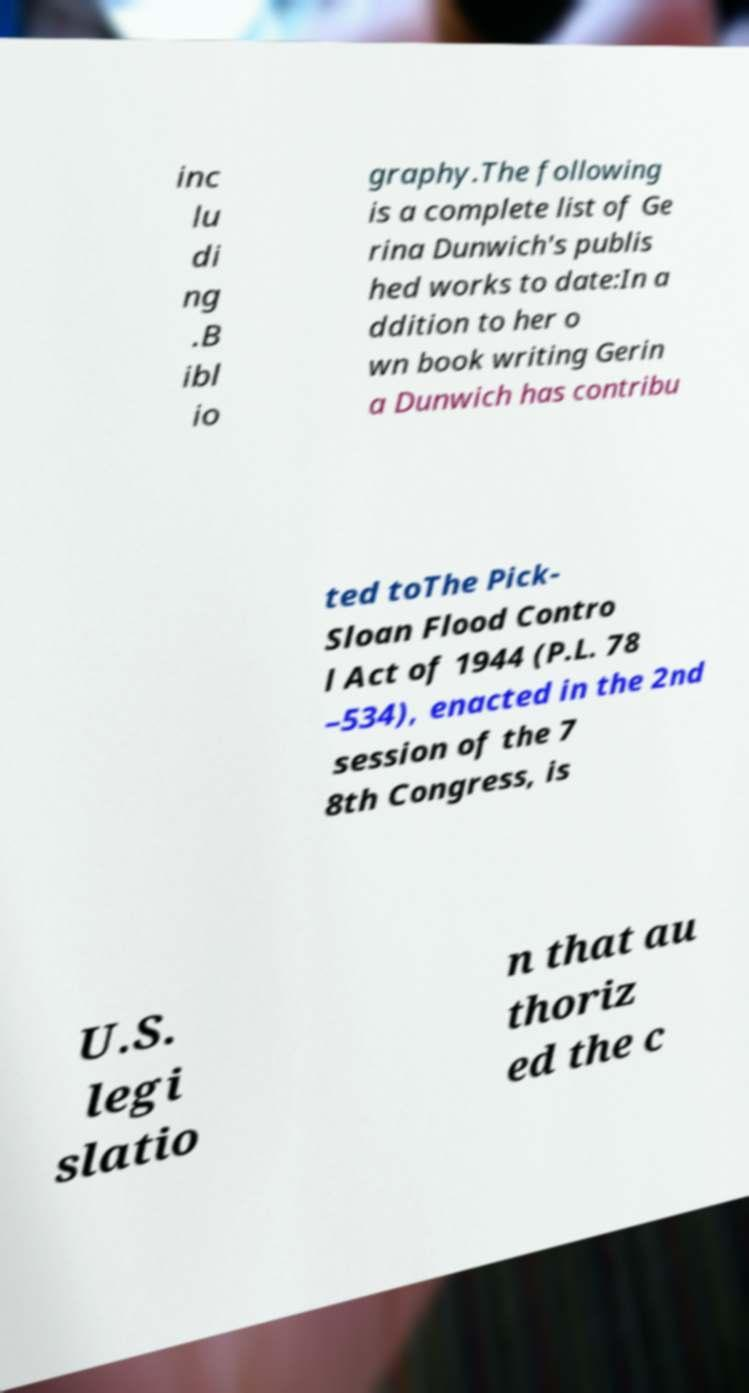Please read and relay the text visible in this image. What does it say? inc lu di ng .B ibl io graphy.The following is a complete list of Ge rina Dunwich's publis hed works to date:In a ddition to her o wn book writing Gerin a Dunwich has contribu ted toThe Pick- Sloan Flood Contro l Act of 1944 (P.L. 78 –534), enacted in the 2nd session of the 7 8th Congress, is U.S. legi slatio n that au thoriz ed the c 